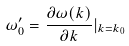<formula> <loc_0><loc_0><loc_500><loc_500>\omega _ { 0 } ^ { \prime } = \frac { \partial \omega ( k ) } { \partial k } | _ { k = k _ { 0 } }</formula> 